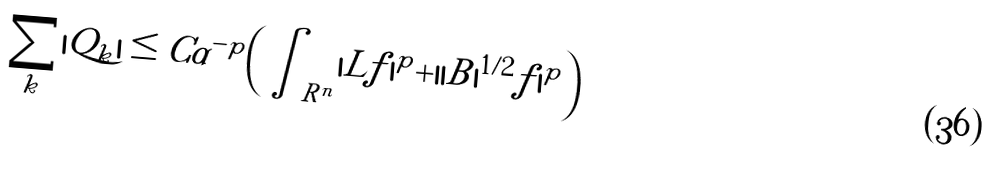<formula> <loc_0><loc_0><loc_500><loc_500>\sum _ { k } | Q _ { k } | \leq C \alpha ^ { - p } \Big { ( } \int _ { R ^ { n } } | L f | ^ { p } + | | B | ^ { 1 / 2 } f | ^ { p } \Big { ) }</formula> 